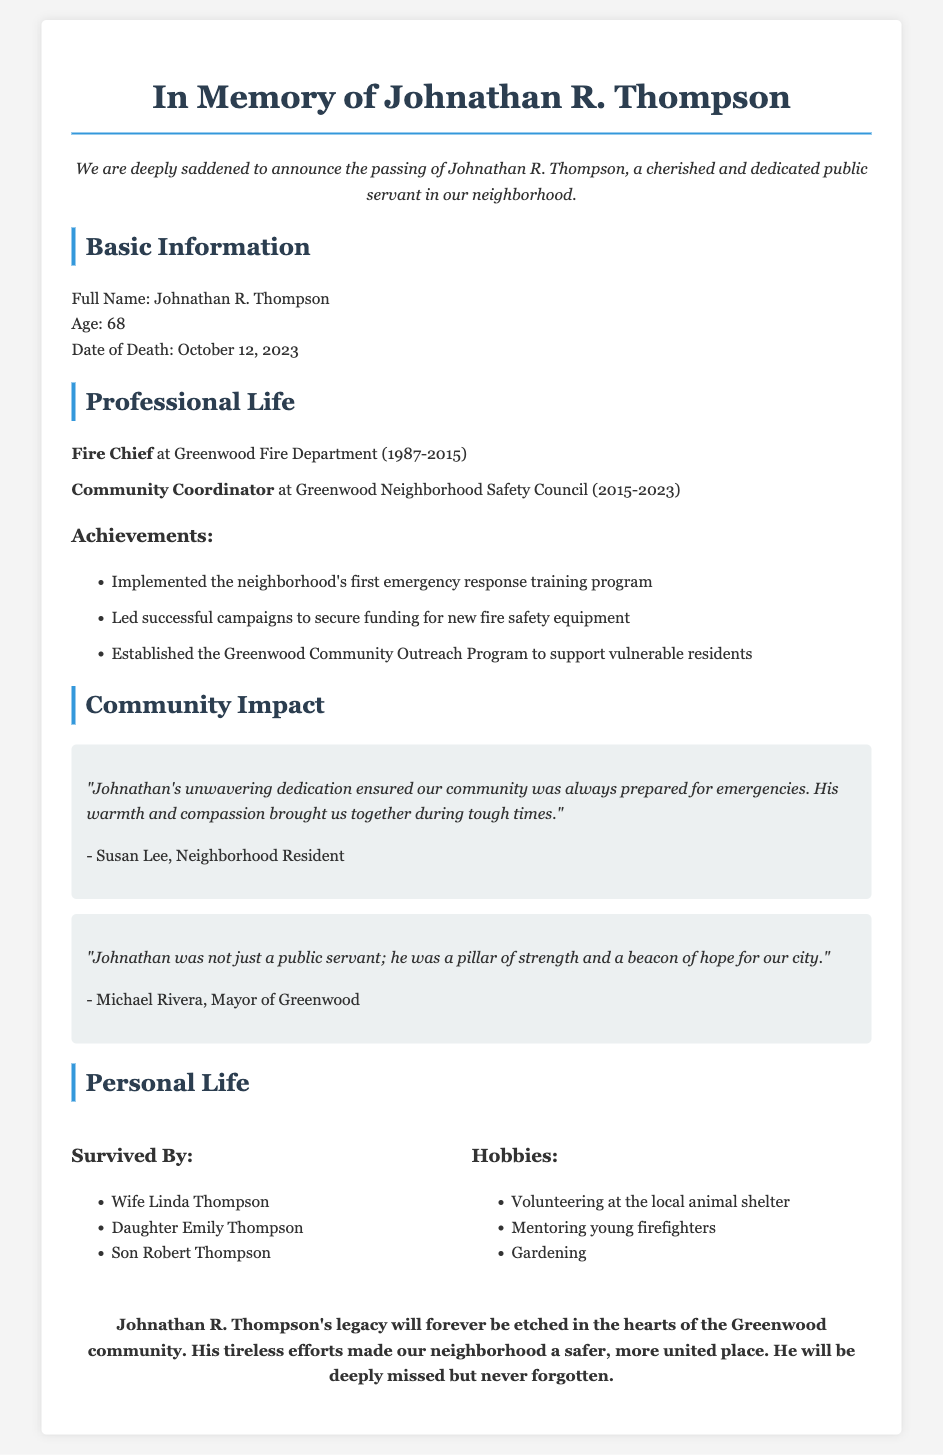What was Johnathan R. Thompson's age at the time of his death? The document states that Johnathan R. Thompson was 68 years old when he passed away on October 12, 2023.
Answer: 68 What position did Johnathan hold at the Greenwood Fire Department? The document lists Johnathan as the Fire Chief at the Greenwood Fire Department from 1987 to 2015.
Answer: Fire Chief What year did Johnathan start working at the Greenwood Neighborhood Safety Council? The document indicates he started as a Community Coordinator at the Greenwood Neighborhood Safety Council in 2015.
Answer: 2015 What was one of Johnathan's key achievements in his professional life? The document highlights multiple achievements, including implementing the neighborhood's first emergency response training program.
Answer: Emergency response training program According to a testimonial, what quality did Johnathan exhibit that benefited the community? Susan Lee’s testimonial expresses that Johnathan's unwavering dedication ensured community preparedness during emergencies.
Answer: Dedication 